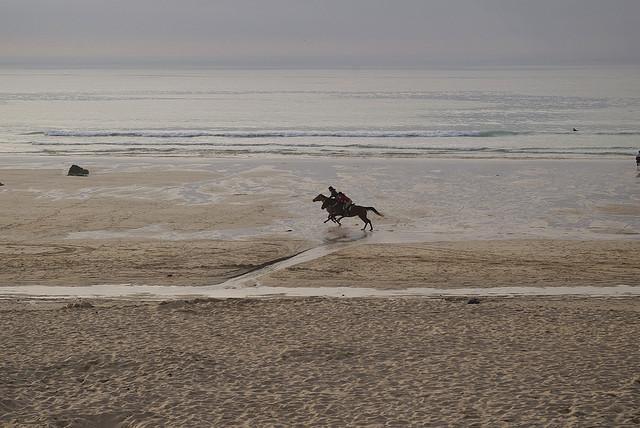How many cars have their lights on?
Give a very brief answer. 0. 